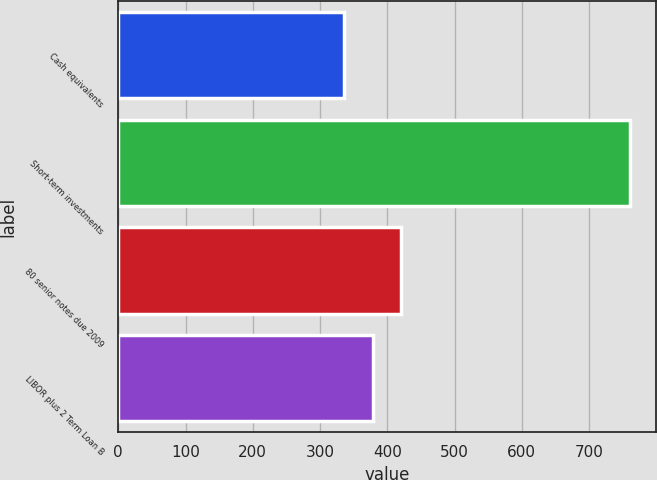Convert chart to OTSL. <chart><loc_0><loc_0><loc_500><loc_500><bar_chart><fcel>Cash equivalents<fcel>Short-term investments<fcel>80 senior notes due 2009<fcel>LIBOR plus 2 Term Loan B<nl><fcel>336<fcel>761<fcel>421<fcel>378.5<nl></chart> 